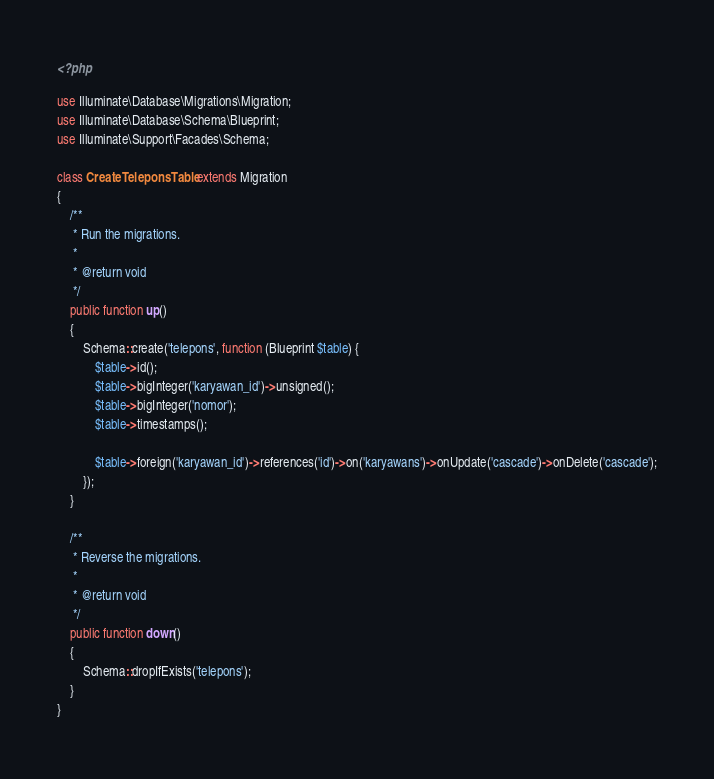Convert code to text. <code><loc_0><loc_0><loc_500><loc_500><_PHP_><?php

use Illuminate\Database\Migrations\Migration;
use Illuminate\Database\Schema\Blueprint;
use Illuminate\Support\Facades\Schema;

class CreateTeleponsTable extends Migration
{
    /**
     * Run the migrations.
     *
     * @return void
     */
    public function up()
    {
        Schema::create('telepons', function (Blueprint $table) {
            $table->id();
            $table->bigInteger('karyawan_id')->unsigned();
            $table->bigInteger('nomor');
            $table->timestamps();

            $table->foreign('karyawan_id')->references('id')->on('karyawans')->onUpdate('cascade')->onDelete('cascade');
        });
    }

    /**
     * Reverse the migrations.
     *
     * @return void
     */
    public function down()
    {
        Schema::dropIfExists('telepons');
    }
}
</code> 